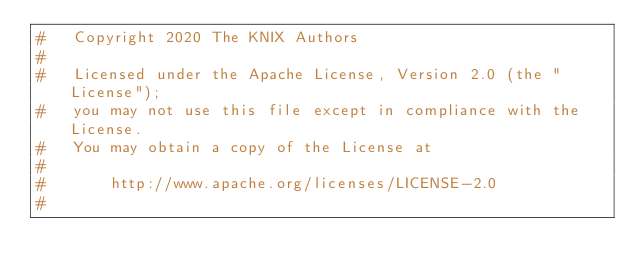Convert code to text. <code><loc_0><loc_0><loc_500><loc_500><_Python_>#   Copyright 2020 The KNIX Authors
#
#   Licensed under the Apache License, Version 2.0 (the "License");
#   you may not use this file except in compliance with the License.
#   You may obtain a copy of the License at
#
#       http://www.apache.org/licenses/LICENSE-2.0
#</code> 